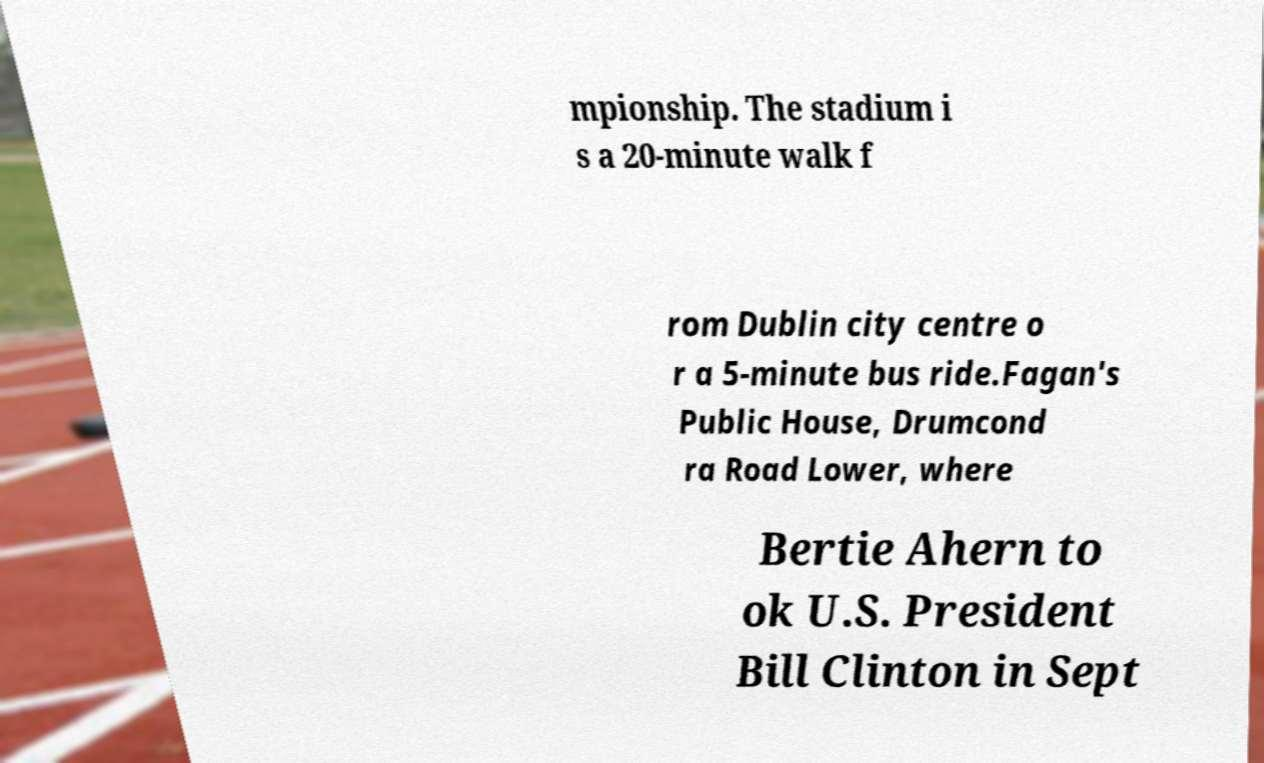Please identify and transcribe the text found in this image. mpionship. The stadium i s a 20-minute walk f rom Dublin city centre o r a 5-minute bus ride.Fagan's Public House, Drumcond ra Road Lower, where Bertie Ahern to ok U.S. President Bill Clinton in Sept 